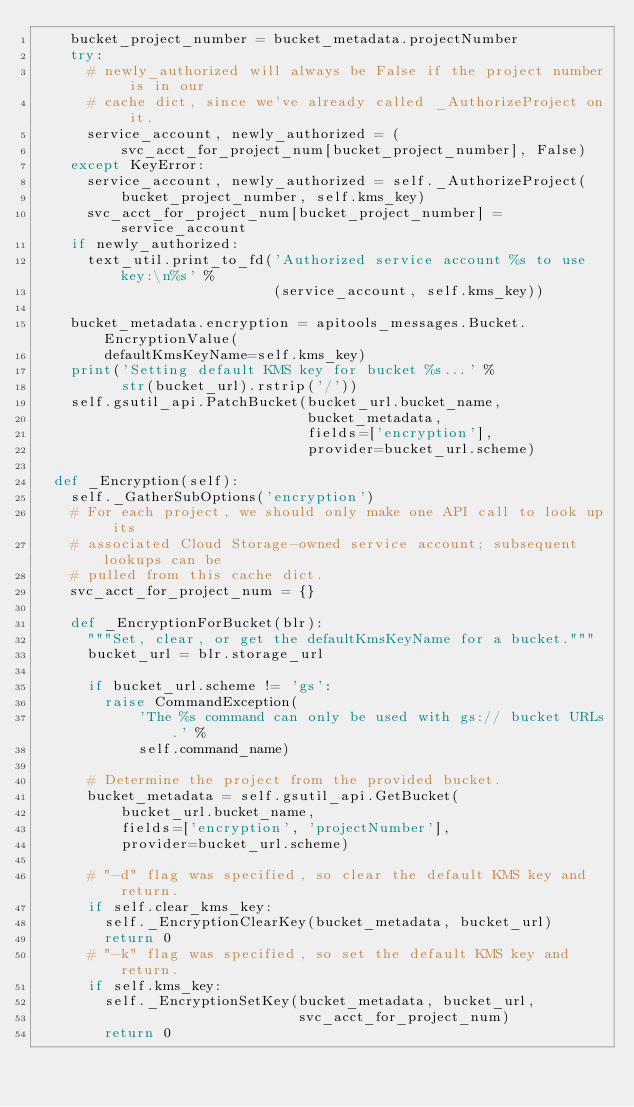Convert code to text. <code><loc_0><loc_0><loc_500><loc_500><_Python_>    bucket_project_number = bucket_metadata.projectNumber
    try:
      # newly_authorized will always be False if the project number is in our
      # cache dict, since we've already called _AuthorizeProject on it.
      service_account, newly_authorized = (
          svc_acct_for_project_num[bucket_project_number], False)
    except KeyError:
      service_account, newly_authorized = self._AuthorizeProject(
          bucket_project_number, self.kms_key)
      svc_acct_for_project_num[bucket_project_number] = service_account
    if newly_authorized:
      text_util.print_to_fd('Authorized service account %s to use key:\n%s' %
                            (service_account, self.kms_key))

    bucket_metadata.encryption = apitools_messages.Bucket.EncryptionValue(
        defaultKmsKeyName=self.kms_key)
    print('Setting default KMS key for bucket %s...' %
          str(bucket_url).rstrip('/'))
    self.gsutil_api.PatchBucket(bucket_url.bucket_name,
                                bucket_metadata,
                                fields=['encryption'],
                                provider=bucket_url.scheme)

  def _Encryption(self):
    self._GatherSubOptions('encryption')
    # For each project, we should only make one API call to look up its
    # associated Cloud Storage-owned service account; subsequent lookups can be
    # pulled from this cache dict.
    svc_acct_for_project_num = {}

    def _EncryptionForBucket(blr):
      """Set, clear, or get the defaultKmsKeyName for a bucket."""
      bucket_url = blr.storage_url

      if bucket_url.scheme != 'gs':
        raise CommandException(
            'The %s command can only be used with gs:// bucket URLs.' %
            self.command_name)

      # Determine the project from the provided bucket.
      bucket_metadata = self.gsutil_api.GetBucket(
          bucket_url.bucket_name,
          fields=['encryption', 'projectNumber'],
          provider=bucket_url.scheme)

      # "-d" flag was specified, so clear the default KMS key and return.
      if self.clear_kms_key:
        self._EncryptionClearKey(bucket_metadata, bucket_url)
        return 0
      # "-k" flag was specified, so set the default KMS key and return.
      if self.kms_key:
        self._EncryptionSetKey(bucket_metadata, bucket_url,
                               svc_acct_for_project_num)
        return 0</code> 